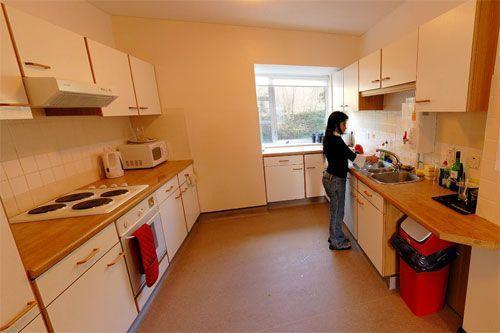How many people are there?
Give a very brief answer. 1. How many white dogs are there?
Give a very brief answer. 0. 